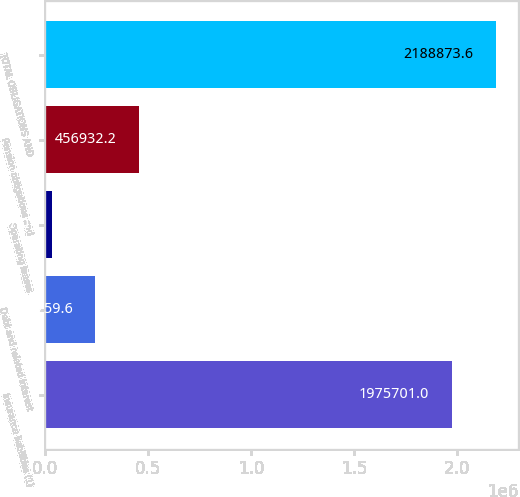<chart> <loc_0><loc_0><loc_500><loc_500><bar_chart><fcel>Insurance liabilities (1)<fcel>Debt and related interest<fcel>Operating leases<fcel>Pension obligations and<fcel>TOTAL OBLIGATIONS AND<nl><fcel>1.9757e+06<fcel>243760<fcel>30587<fcel>456932<fcel>2.18887e+06<nl></chart> 